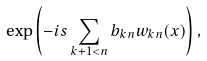Convert formula to latex. <formula><loc_0><loc_0><loc_500><loc_500>\exp \left ( - i s \sum _ { k + 1 < n } b _ { k n } w _ { k n } ( x ) \right ) ,</formula> 